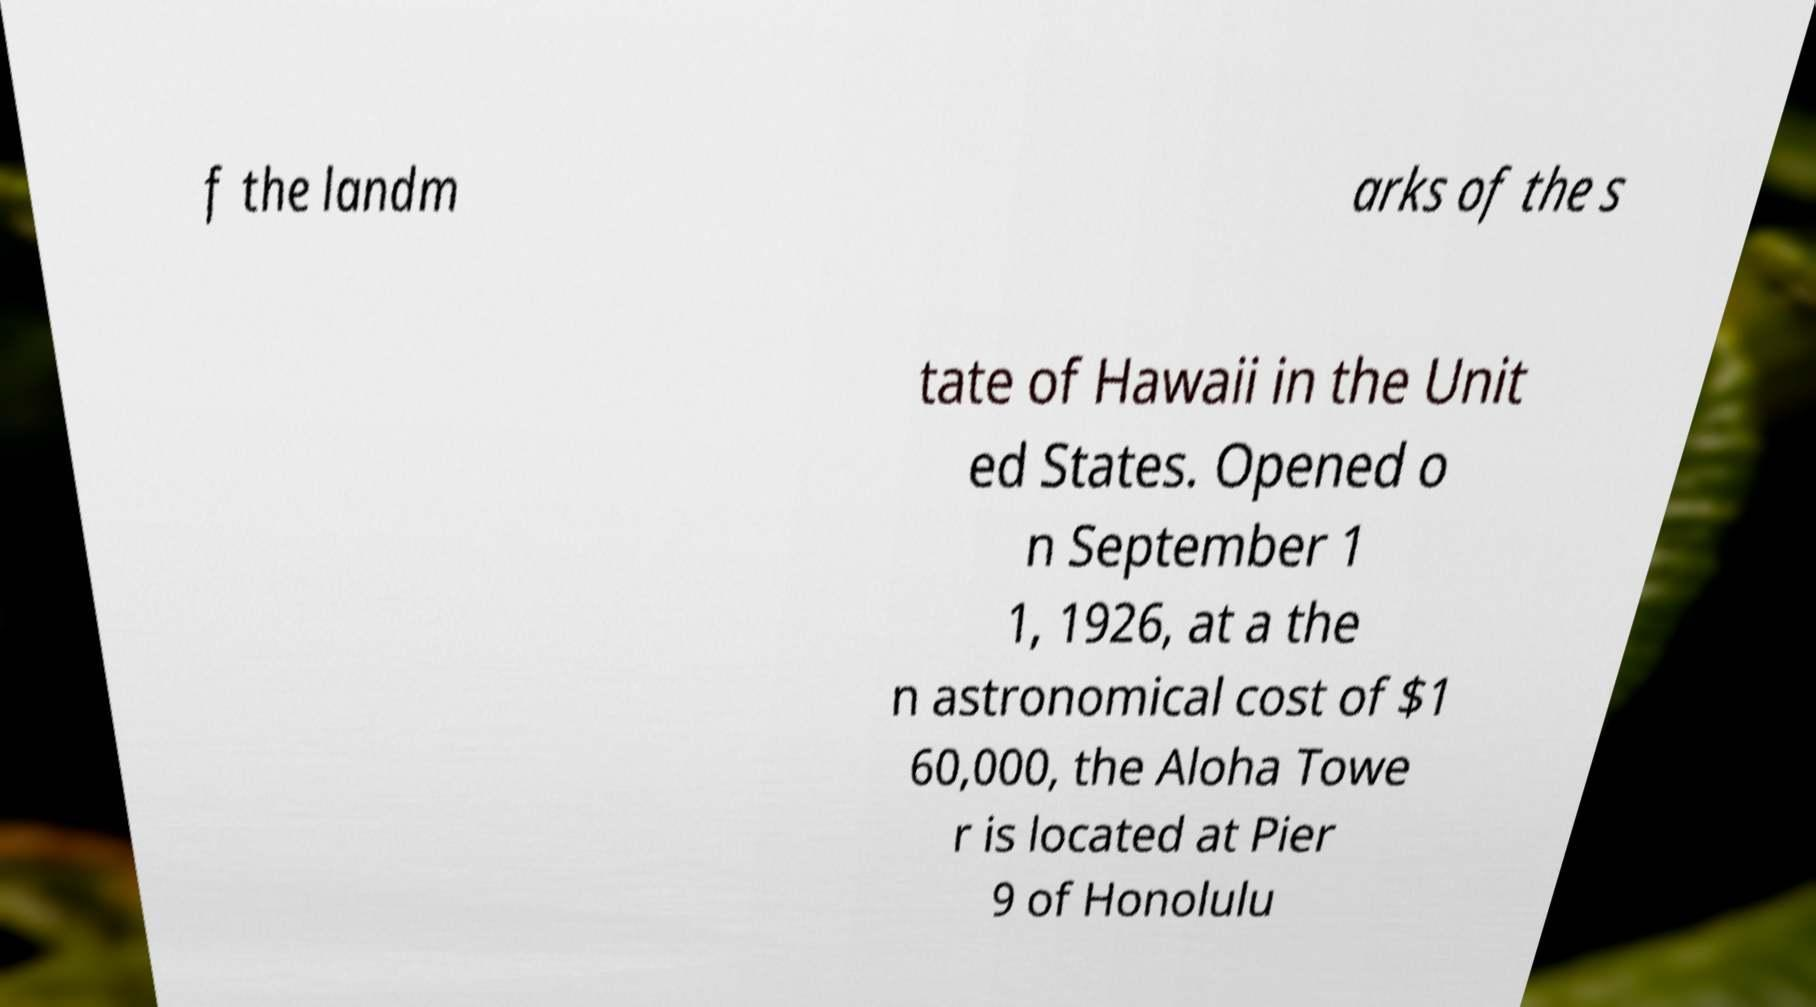Could you extract and type out the text from this image? f the landm arks of the s tate of Hawaii in the Unit ed States. Opened o n September 1 1, 1926, at a the n astronomical cost of $1 60,000, the Aloha Towe r is located at Pier 9 of Honolulu 